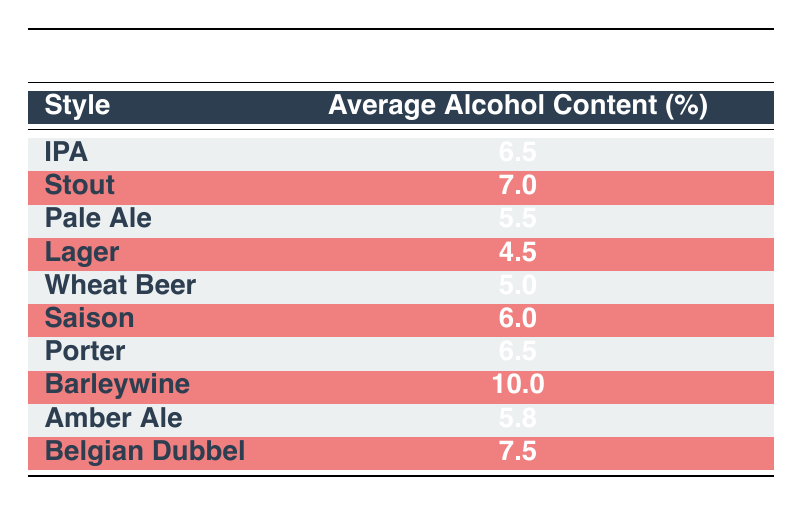What is the average alcohol content of the Stout? The table shows that the average alcohol content for Stout is listed under the corresponding style, which is 7.0%.
Answer: 7.0% Which beer style has the lowest average alcohol content? According to the table, Lager has the lowest average alcohol content at 4.5%.
Answer: Lager Is the average alcohol content of Belgian Dubbel greater than 8%? To determine if Belgian Dubbel's alcohol content is greater than 8%, we check the table and see it is listed as 7.5%, which is not greater than 8%.
Answer: No What is the difference in average alcohol content between Barleywine and Lager? The average alcohol content for Barleywine is 10.0% and for Lager is 4.5%. To find the difference, we subtract 4.5 from 10.0, giving us 5.5%.
Answer: 5.5% What is the average alcohol content of all beer styles listed? The average is calculated by adding all the average alcohol contents: (6.5 + 7.0 + 5.5 + 4.5 + 5.0 + 6.0 + 6.5 + 10.0 + 5.8 + 7.5) = 60.8. Since there are 10 styles, we divide 60.8 by 10, resulting in an average of 6.08%.
Answer: 6.08% Does Pale Ale have a higher average alcohol content than Wheat Beer? The table shows that Pale Ale has an average alcohol content of 5.5% and Wheat Beer has 5.0%. Comparing these values, Pale Ale indeed has a higher content.
Answer: Yes What are the styles that have an average alcohol content of 6.5%? To identify the styles with 6.5%, we look at the table and find that both IPA and Porter have that alcohol content listed.
Answer: IPA, Porter Which style has an average alcohol content closest to 6%? Checking the table, Saison has an average of 6.0% which is the exact match. However, the next closest is IPA at 6.5%. Thus, Saison is the closest.
Answer: Saison 